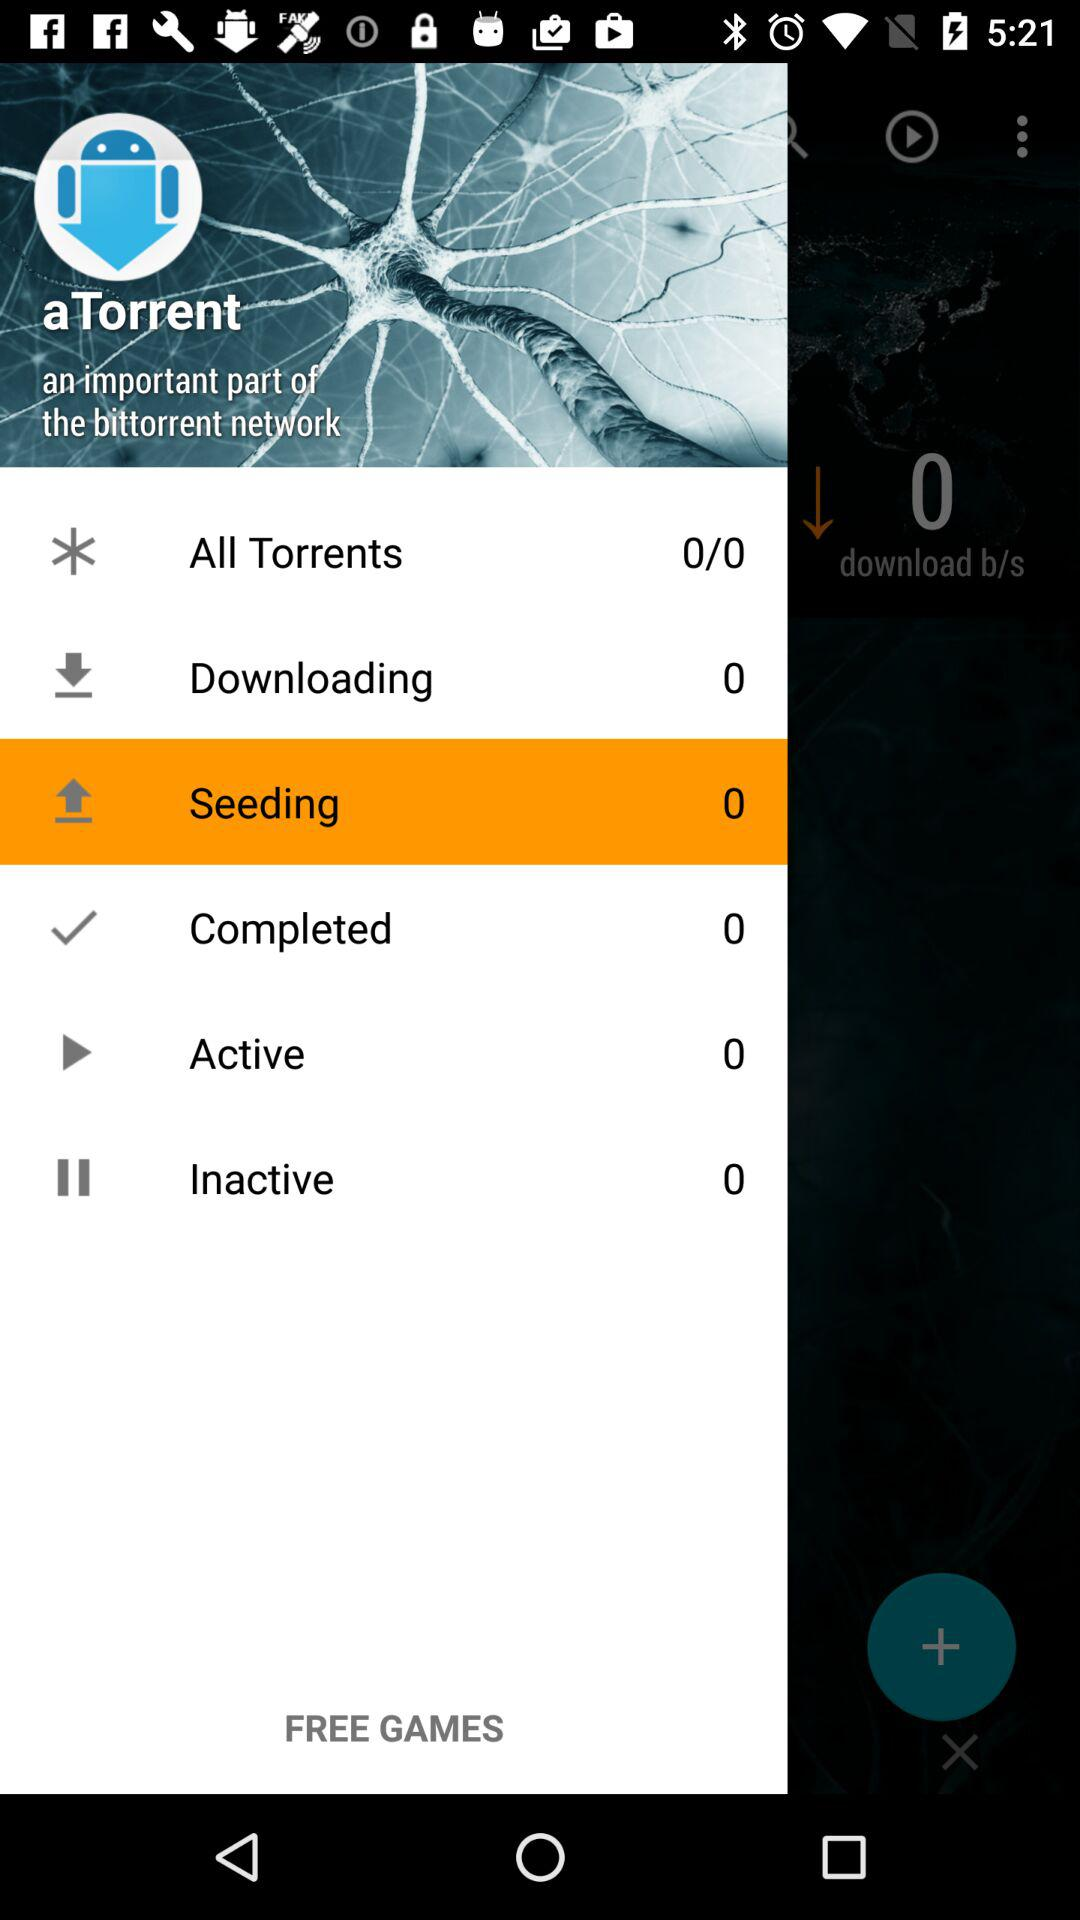What is the number of "downloading"? The number of "downloading" is 0. 